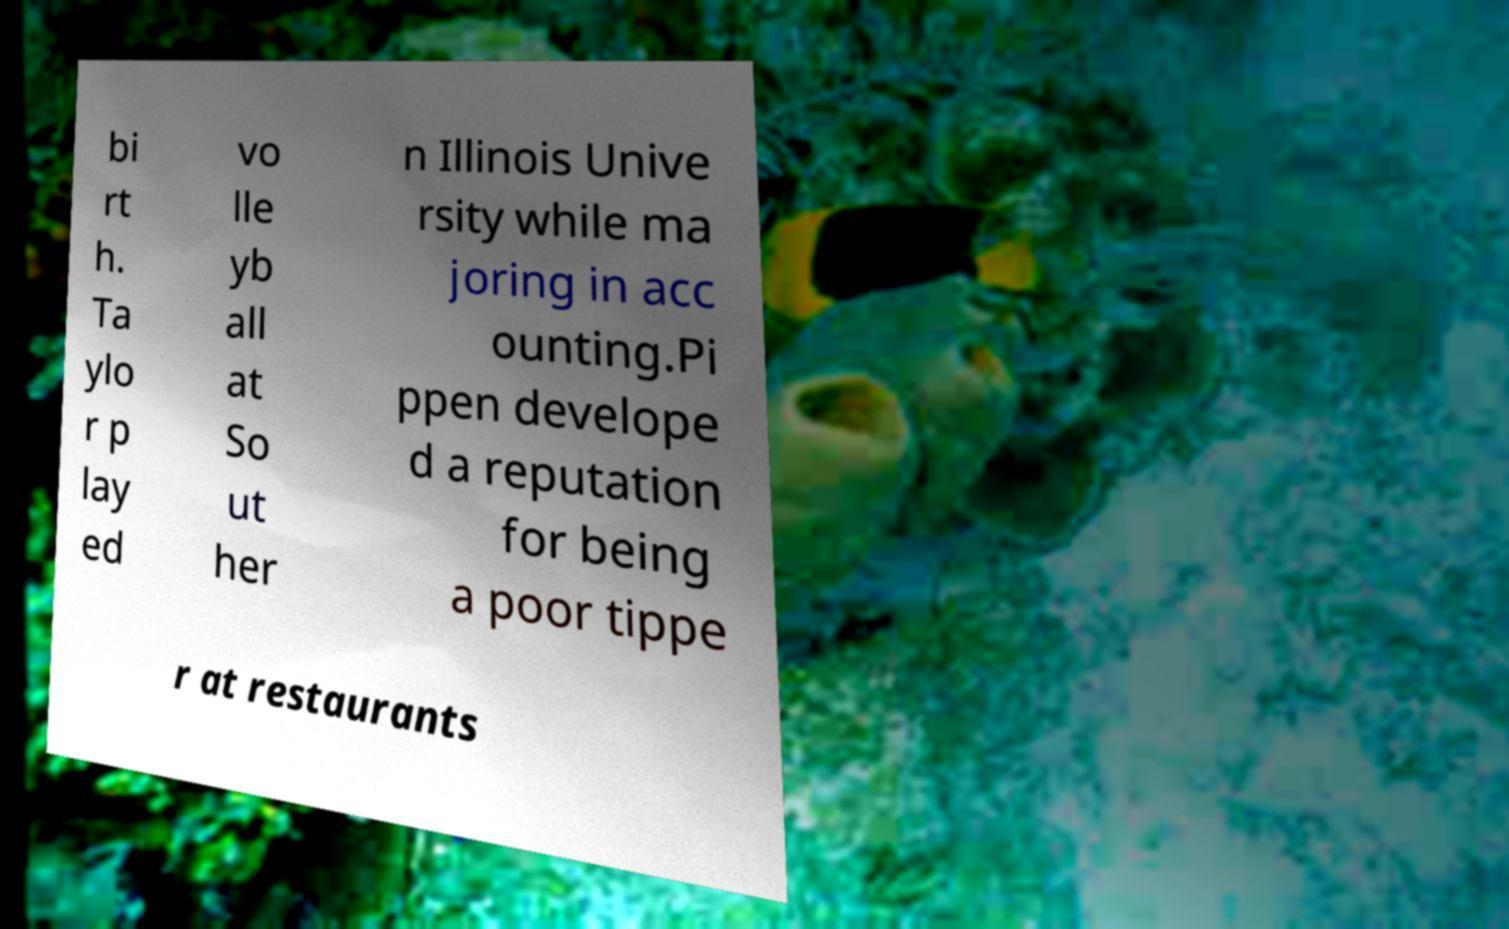Please identify and transcribe the text found in this image. bi rt h. Ta ylo r p lay ed vo lle yb all at So ut her n Illinois Unive rsity while ma joring in acc ounting.Pi ppen develope d a reputation for being a poor tippe r at restaurants 